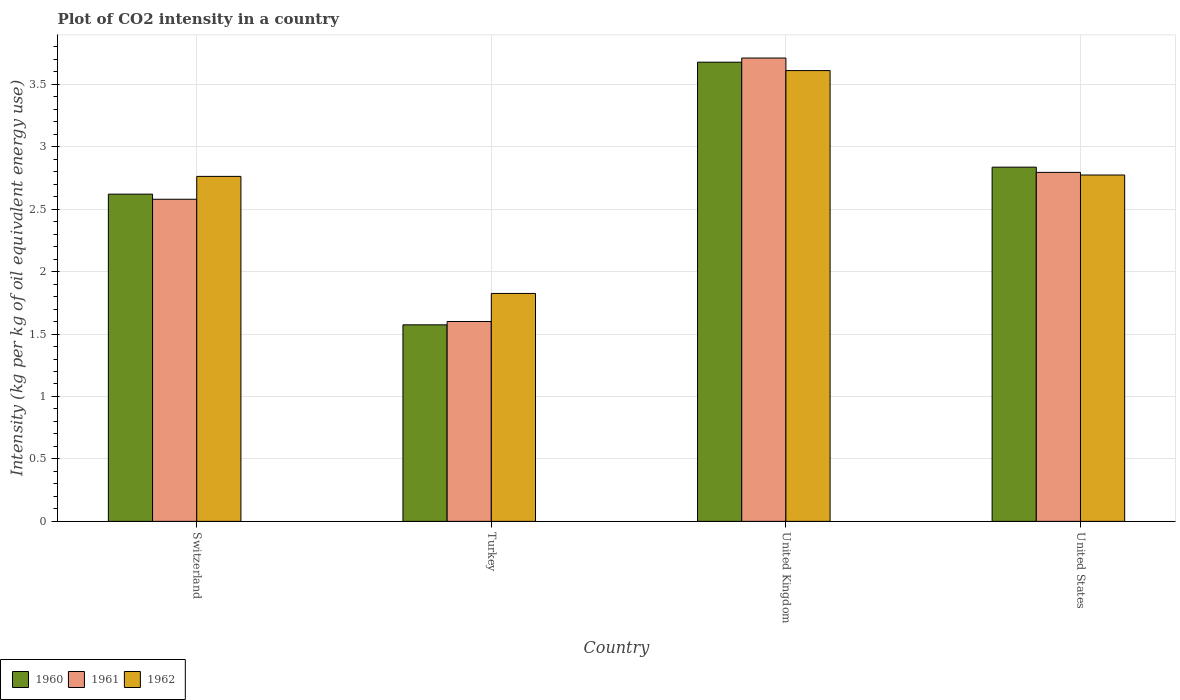Are the number of bars on each tick of the X-axis equal?
Offer a very short reply. Yes. How many bars are there on the 2nd tick from the right?
Offer a very short reply. 3. What is the CO2 intensity in in 1960 in United Kingdom?
Provide a short and direct response. 3.68. Across all countries, what is the maximum CO2 intensity in in 1961?
Make the answer very short. 3.71. Across all countries, what is the minimum CO2 intensity in in 1962?
Your answer should be compact. 1.82. In which country was the CO2 intensity in in 1962 maximum?
Make the answer very short. United Kingdom. In which country was the CO2 intensity in in 1962 minimum?
Give a very brief answer. Turkey. What is the total CO2 intensity in in 1962 in the graph?
Provide a short and direct response. 10.97. What is the difference between the CO2 intensity in in 1962 in Turkey and that in United States?
Give a very brief answer. -0.95. What is the difference between the CO2 intensity in in 1962 in Switzerland and the CO2 intensity in in 1960 in United States?
Your answer should be compact. -0.07. What is the average CO2 intensity in in 1962 per country?
Offer a terse response. 2.74. What is the difference between the CO2 intensity in of/in 1961 and CO2 intensity in of/in 1962 in Turkey?
Provide a succinct answer. -0.22. In how many countries, is the CO2 intensity in in 1961 greater than 1.3 kg?
Give a very brief answer. 4. What is the ratio of the CO2 intensity in in 1961 in Switzerland to that in Turkey?
Ensure brevity in your answer.  1.61. What is the difference between the highest and the second highest CO2 intensity in in 1961?
Offer a very short reply. -0.92. What is the difference between the highest and the lowest CO2 intensity in in 1962?
Your answer should be compact. 1.78. In how many countries, is the CO2 intensity in in 1962 greater than the average CO2 intensity in in 1962 taken over all countries?
Offer a very short reply. 3. What does the 2nd bar from the right in Switzerland represents?
Provide a succinct answer. 1961. How many bars are there?
Your answer should be very brief. 12. Are all the bars in the graph horizontal?
Offer a very short reply. No. How many countries are there in the graph?
Keep it short and to the point. 4. What is the difference between two consecutive major ticks on the Y-axis?
Give a very brief answer. 0.5. Are the values on the major ticks of Y-axis written in scientific E-notation?
Your response must be concise. No. Does the graph contain grids?
Keep it short and to the point. Yes. Where does the legend appear in the graph?
Keep it short and to the point. Bottom left. How are the legend labels stacked?
Make the answer very short. Horizontal. What is the title of the graph?
Provide a succinct answer. Plot of CO2 intensity in a country. What is the label or title of the X-axis?
Your response must be concise. Country. What is the label or title of the Y-axis?
Keep it short and to the point. Intensity (kg per kg of oil equivalent energy use). What is the Intensity (kg per kg of oil equivalent energy use) in 1960 in Switzerland?
Your response must be concise. 2.62. What is the Intensity (kg per kg of oil equivalent energy use) of 1961 in Switzerland?
Your answer should be compact. 2.58. What is the Intensity (kg per kg of oil equivalent energy use) of 1962 in Switzerland?
Offer a terse response. 2.76. What is the Intensity (kg per kg of oil equivalent energy use) in 1960 in Turkey?
Give a very brief answer. 1.57. What is the Intensity (kg per kg of oil equivalent energy use) of 1961 in Turkey?
Make the answer very short. 1.6. What is the Intensity (kg per kg of oil equivalent energy use) in 1962 in Turkey?
Your response must be concise. 1.82. What is the Intensity (kg per kg of oil equivalent energy use) of 1960 in United Kingdom?
Ensure brevity in your answer.  3.68. What is the Intensity (kg per kg of oil equivalent energy use) of 1961 in United Kingdom?
Make the answer very short. 3.71. What is the Intensity (kg per kg of oil equivalent energy use) of 1962 in United Kingdom?
Give a very brief answer. 3.61. What is the Intensity (kg per kg of oil equivalent energy use) of 1960 in United States?
Ensure brevity in your answer.  2.84. What is the Intensity (kg per kg of oil equivalent energy use) in 1961 in United States?
Make the answer very short. 2.79. What is the Intensity (kg per kg of oil equivalent energy use) of 1962 in United States?
Make the answer very short. 2.77. Across all countries, what is the maximum Intensity (kg per kg of oil equivalent energy use) in 1960?
Ensure brevity in your answer.  3.68. Across all countries, what is the maximum Intensity (kg per kg of oil equivalent energy use) of 1961?
Make the answer very short. 3.71. Across all countries, what is the maximum Intensity (kg per kg of oil equivalent energy use) in 1962?
Make the answer very short. 3.61. Across all countries, what is the minimum Intensity (kg per kg of oil equivalent energy use) of 1960?
Provide a succinct answer. 1.57. Across all countries, what is the minimum Intensity (kg per kg of oil equivalent energy use) in 1961?
Your answer should be compact. 1.6. Across all countries, what is the minimum Intensity (kg per kg of oil equivalent energy use) in 1962?
Offer a very short reply. 1.82. What is the total Intensity (kg per kg of oil equivalent energy use) in 1960 in the graph?
Ensure brevity in your answer.  10.71. What is the total Intensity (kg per kg of oil equivalent energy use) in 1961 in the graph?
Provide a short and direct response. 10.68. What is the total Intensity (kg per kg of oil equivalent energy use) in 1962 in the graph?
Give a very brief answer. 10.97. What is the difference between the Intensity (kg per kg of oil equivalent energy use) of 1960 in Switzerland and that in Turkey?
Your answer should be very brief. 1.05. What is the difference between the Intensity (kg per kg of oil equivalent energy use) of 1961 in Switzerland and that in Turkey?
Provide a short and direct response. 0.98. What is the difference between the Intensity (kg per kg of oil equivalent energy use) of 1962 in Switzerland and that in Turkey?
Provide a short and direct response. 0.94. What is the difference between the Intensity (kg per kg of oil equivalent energy use) in 1960 in Switzerland and that in United Kingdom?
Make the answer very short. -1.06. What is the difference between the Intensity (kg per kg of oil equivalent energy use) of 1961 in Switzerland and that in United Kingdom?
Ensure brevity in your answer.  -1.13. What is the difference between the Intensity (kg per kg of oil equivalent energy use) in 1962 in Switzerland and that in United Kingdom?
Offer a very short reply. -0.85. What is the difference between the Intensity (kg per kg of oil equivalent energy use) of 1960 in Switzerland and that in United States?
Your response must be concise. -0.22. What is the difference between the Intensity (kg per kg of oil equivalent energy use) of 1961 in Switzerland and that in United States?
Offer a terse response. -0.22. What is the difference between the Intensity (kg per kg of oil equivalent energy use) in 1962 in Switzerland and that in United States?
Give a very brief answer. -0.01. What is the difference between the Intensity (kg per kg of oil equivalent energy use) of 1960 in Turkey and that in United Kingdom?
Ensure brevity in your answer.  -2.1. What is the difference between the Intensity (kg per kg of oil equivalent energy use) in 1961 in Turkey and that in United Kingdom?
Your response must be concise. -2.11. What is the difference between the Intensity (kg per kg of oil equivalent energy use) of 1962 in Turkey and that in United Kingdom?
Ensure brevity in your answer.  -1.78. What is the difference between the Intensity (kg per kg of oil equivalent energy use) of 1960 in Turkey and that in United States?
Ensure brevity in your answer.  -1.26. What is the difference between the Intensity (kg per kg of oil equivalent energy use) of 1961 in Turkey and that in United States?
Provide a succinct answer. -1.19. What is the difference between the Intensity (kg per kg of oil equivalent energy use) in 1962 in Turkey and that in United States?
Give a very brief answer. -0.95. What is the difference between the Intensity (kg per kg of oil equivalent energy use) of 1960 in United Kingdom and that in United States?
Offer a terse response. 0.84. What is the difference between the Intensity (kg per kg of oil equivalent energy use) of 1961 in United Kingdom and that in United States?
Offer a terse response. 0.92. What is the difference between the Intensity (kg per kg of oil equivalent energy use) in 1962 in United Kingdom and that in United States?
Offer a very short reply. 0.84. What is the difference between the Intensity (kg per kg of oil equivalent energy use) of 1960 in Switzerland and the Intensity (kg per kg of oil equivalent energy use) of 1961 in Turkey?
Ensure brevity in your answer.  1.02. What is the difference between the Intensity (kg per kg of oil equivalent energy use) of 1960 in Switzerland and the Intensity (kg per kg of oil equivalent energy use) of 1962 in Turkey?
Make the answer very short. 0.8. What is the difference between the Intensity (kg per kg of oil equivalent energy use) of 1961 in Switzerland and the Intensity (kg per kg of oil equivalent energy use) of 1962 in Turkey?
Offer a very short reply. 0.75. What is the difference between the Intensity (kg per kg of oil equivalent energy use) of 1960 in Switzerland and the Intensity (kg per kg of oil equivalent energy use) of 1961 in United Kingdom?
Offer a very short reply. -1.09. What is the difference between the Intensity (kg per kg of oil equivalent energy use) of 1960 in Switzerland and the Intensity (kg per kg of oil equivalent energy use) of 1962 in United Kingdom?
Make the answer very short. -0.99. What is the difference between the Intensity (kg per kg of oil equivalent energy use) of 1961 in Switzerland and the Intensity (kg per kg of oil equivalent energy use) of 1962 in United Kingdom?
Your answer should be very brief. -1.03. What is the difference between the Intensity (kg per kg of oil equivalent energy use) in 1960 in Switzerland and the Intensity (kg per kg of oil equivalent energy use) in 1961 in United States?
Keep it short and to the point. -0.17. What is the difference between the Intensity (kg per kg of oil equivalent energy use) of 1960 in Switzerland and the Intensity (kg per kg of oil equivalent energy use) of 1962 in United States?
Provide a succinct answer. -0.15. What is the difference between the Intensity (kg per kg of oil equivalent energy use) of 1961 in Switzerland and the Intensity (kg per kg of oil equivalent energy use) of 1962 in United States?
Offer a very short reply. -0.19. What is the difference between the Intensity (kg per kg of oil equivalent energy use) of 1960 in Turkey and the Intensity (kg per kg of oil equivalent energy use) of 1961 in United Kingdom?
Offer a terse response. -2.14. What is the difference between the Intensity (kg per kg of oil equivalent energy use) of 1960 in Turkey and the Intensity (kg per kg of oil equivalent energy use) of 1962 in United Kingdom?
Your answer should be compact. -2.04. What is the difference between the Intensity (kg per kg of oil equivalent energy use) of 1961 in Turkey and the Intensity (kg per kg of oil equivalent energy use) of 1962 in United Kingdom?
Your response must be concise. -2.01. What is the difference between the Intensity (kg per kg of oil equivalent energy use) in 1960 in Turkey and the Intensity (kg per kg of oil equivalent energy use) in 1961 in United States?
Make the answer very short. -1.22. What is the difference between the Intensity (kg per kg of oil equivalent energy use) of 1960 in Turkey and the Intensity (kg per kg of oil equivalent energy use) of 1962 in United States?
Offer a terse response. -1.2. What is the difference between the Intensity (kg per kg of oil equivalent energy use) of 1961 in Turkey and the Intensity (kg per kg of oil equivalent energy use) of 1962 in United States?
Provide a succinct answer. -1.17. What is the difference between the Intensity (kg per kg of oil equivalent energy use) of 1960 in United Kingdom and the Intensity (kg per kg of oil equivalent energy use) of 1961 in United States?
Offer a terse response. 0.88. What is the difference between the Intensity (kg per kg of oil equivalent energy use) in 1960 in United Kingdom and the Intensity (kg per kg of oil equivalent energy use) in 1962 in United States?
Your response must be concise. 0.9. What is the difference between the Intensity (kg per kg of oil equivalent energy use) in 1961 in United Kingdom and the Intensity (kg per kg of oil equivalent energy use) in 1962 in United States?
Your answer should be compact. 0.94. What is the average Intensity (kg per kg of oil equivalent energy use) in 1960 per country?
Your answer should be compact. 2.68. What is the average Intensity (kg per kg of oil equivalent energy use) in 1961 per country?
Make the answer very short. 2.67. What is the average Intensity (kg per kg of oil equivalent energy use) of 1962 per country?
Provide a short and direct response. 2.74. What is the difference between the Intensity (kg per kg of oil equivalent energy use) of 1960 and Intensity (kg per kg of oil equivalent energy use) of 1961 in Switzerland?
Your response must be concise. 0.04. What is the difference between the Intensity (kg per kg of oil equivalent energy use) in 1960 and Intensity (kg per kg of oil equivalent energy use) in 1962 in Switzerland?
Offer a very short reply. -0.14. What is the difference between the Intensity (kg per kg of oil equivalent energy use) in 1961 and Intensity (kg per kg of oil equivalent energy use) in 1962 in Switzerland?
Your answer should be compact. -0.18. What is the difference between the Intensity (kg per kg of oil equivalent energy use) of 1960 and Intensity (kg per kg of oil equivalent energy use) of 1961 in Turkey?
Provide a succinct answer. -0.03. What is the difference between the Intensity (kg per kg of oil equivalent energy use) in 1960 and Intensity (kg per kg of oil equivalent energy use) in 1962 in Turkey?
Offer a very short reply. -0.25. What is the difference between the Intensity (kg per kg of oil equivalent energy use) of 1961 and Intensity (kg per kg of oil equivalent energy use) of 1962 in Turkey?
Give a very brief answer. -0.22. What is the difference between the Intensity (kg per kg of oil equivalent energy use) in 1960 and Intensity (kg per kg of oil equivalent energy use) in 1961 in United Kingdom?
Provide a short and direct response. -0.03. What is the difference between the Intensity (kg per kg of oil equivalent energy use) of 1960 and Intensity (kg per kg of oil equivalent energy use) of 1962 in United Kingdom?
Your answer should be very brief. 0.07. What is the difference between the Intensity (kg per kg of oil equivalent energy use) in 1961 and Intensity (kg per kg of oil equivalent energy use) in 1962 in United Kingdom?
Offer a terse response. 0.1. What is the difference between the Intensity (kg per kg of oil equivalent energy use) in 1960 and Intensity (kg per kg of oil equivalent energy use) in 1961 in United States?
Make the answer very short. 0.04. What is the difference between the Intensity (kg per kg of oil equivalent energy use) of 1960 and Intensity (kg per kg of oil equivalent energy use) of 1962 in United States?
Keep it short and to the point. 0.06. What is the difference between the Intensity (kg per kg of oil equivalent energy use) of 1961 and Intensity (kg per kg of oil equivalent energy use) of 1962 in United States?
Your answer should be very brief. 0.02. What is the ratio of the Intensity (kg per kg of oil equivalent energy use) in 1960 in Switzerland to that in Turkey?
Your response must be concise. 1.67. What is the ratio of the Intensity (kg per kg of oil equivalent energy use) in 1961 in Switzerland to that in Turkey?
Ensure brevity in your answer.  1.61. What is the ratio of the Intensity (kg per kg of oil equivalent energy use) in 1962 in Switzerland to that in Turkey?
Your response must be concise. 1.51. What is the ratio of the Intensity (kg per kg of oil equivalent energy use) in 1960 in Switzerland to that in United Kingdom?
Your answer should be very brief. 0.71. What is the ratio of the Intensity (kg per kg of oil equivalent energy use) in 1961 in Switzerland to that in United Kingdom?
Offer a terse response. 0.7. What is the ratio of the Intensity (kg per kg of oil equivalent energy use) of 1962 in Switzerland to that in United Kingdom?
Provide a short and direct response. 0.77. What is the ratio of the Intensity (kg per kg of oil equivalent energy use) of 1960 in Switzerland to that in United States?
Give a very brief answer. 0.92. What is the ratio of the Intensity (kg per kg of oil equivalent energy use) of 1961 in Switzerland to that in United States?
Offer a terse response. 0.92. What is the ratio of the Intensity (kg per kg of oil equivalent energy use) in 1962 in Switzerland to that in United States?
Give a very brief answer. 1. What is the ratio of the Intensity (kg per kg of oil equivalent energy use) in 1960 in Turkey to that in United Kingdom?
Keep it short and to the point. 0.43. What is the ratio of the Intensity (kg per kg of oil equivalent energy use) of 1961 in Turkey to that in United Kingdom?
Provide a short and direct response. 0.43. What is the ratio of the Intensity (kg per kg of oil equivalent energy use) in 1962 in Turkey to that in United Kingdom?
Make the answer very short. 0.51. What is the ratio of the Intensity (kg per kg of oil equivalent energy use) of 1960 in Turkey to that in United States?
Your answer should be very brief. 0.55. What is the ratio of the Intensity (kg per kg of oil equivalent energy use) in 1961 in Turkey to that in United States?
Give a very brief answer. 0.57. What is the ratio of the Intensity (kg per kg of oil equivalent energy use) of 1962 in Turkey to that in United States?
Offer a very short reply. 0.66. What is the ratio of the Intensity (kg per kg of oil equivalent energy use) of 1960 in United Kingdom to that in United States?
Your answer should be compact. 1.3. What is the ratio of the Intensity (kg per kg of oil equivalent energy use) in 1961 in United Kingdom to that in United States?
Offer a very short reply. 1.33. What is the ratio of the Intensity (kg per kg of oil equivalent energy use) in 1962 in United Kingdom to that in United States?
Provide a short and direct response. 1.3. What is the difference between the highest and the second highest Intensity (kg per kg of oil equivalent energy use) of 1960?
Provide a short and direct response. 0.84. What is the difference between the highest and the second highest Intensity (kg per kg of oil equivalent energy use) of 1961?
Give a very brief answer. 0.92. What is the difference between the highest and the second highest Intensity (kg per kg of oil equivalent energy use) of 1962?
Offer a very short reply. 0.84. What is the difference between the highest and the lowest Intensity (kg per kg of oil equivalent energy use) in 1960?
Provide a short and direct response. 2.1. What is the difference between the highest and the lowest Intensity (kg per kg of oil equivalent energy use) in 1961?
Your response must be concise. 2.11. What is the difference between the highest and the lowest Intensity (kg per kg of oil equivalent energy use) in 1962?
Make the answer very short. 1.78. 